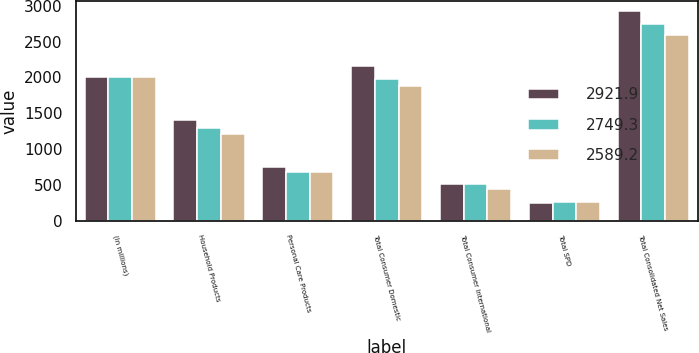Convert chart. <chart><loc_0><loc_0><loc_500><loc_500><stacked_bar_chart><ecel><fcel>(In millions)<fcel>Household Products<fcel>Personal Care Products<fcel>Total Consumer Domestic<fcel>Total Consumer International<fcel>Total SPD<fcel>Total Consolidated Net Sales<nl><fcel>2921.9<fcel>2012<fcel>1411.3<fcel>745.6<fcel>2156.9<fcel>510.1<fcel>254.9<fcel>2921.9<nl><fcel>2749.3<fcel>2011<fcel>1295<fcel>684.1<fcel>1979.1<fcel>509.1<fcel>261.1<fcel>2749.3<nl><fcel>2589.2<fcel>2010<fcel>1207.4<fcel>678.7<fcel>1886.1<fcel>444<fcel>259.1<fcel>2589.2<nl></chart> 